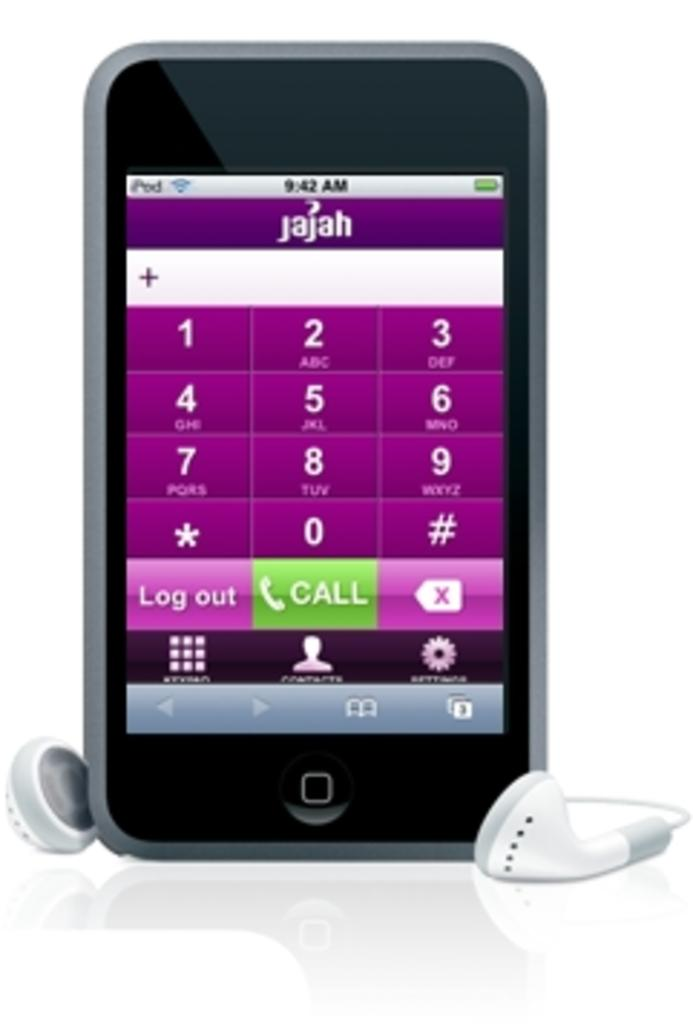What electronic device is visible in the image? There is a mobile phone in the image. What is displayed on the mobile phone's screen? The mobile phone's display shows numbers, text, and other things. What accessory is present on the surface in the image? Earphones are present on the surface in the image. Is your brother visible in the image, standing next to the mobile phone? There is no mention of a brother or any person in the image, so we cannot confirm their presence. 